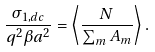<formula> <loc_0><loc_0><loc_500><loc_500>\frac { \sigma _ { 1 , d c } } { q ^ { 2 } \beta a ^ { 2 } } = \left \langle \frac { N } { \sum _ { m } A _ { m } } \right \rangle .</formula> 